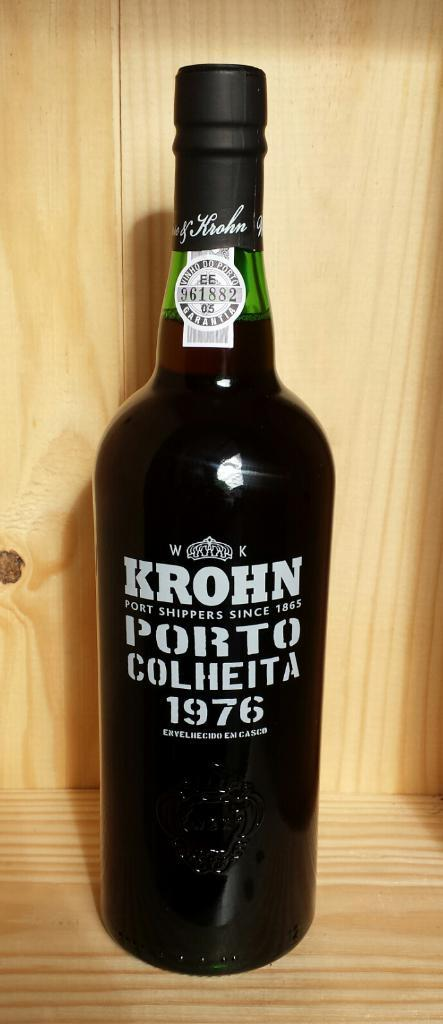What color is the bottle in the image? The bottle in the image is black. How many passengers are in the bottle in the image? There are no passengers present in the bottle, as it is a bottle and not a vehicle or mode of transportation. 